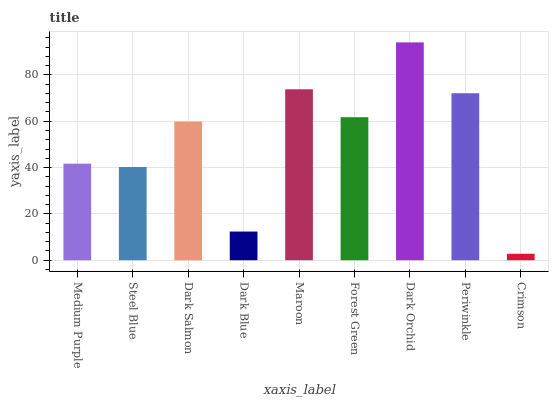Is Crimson the minimum?
Answer yes or no. Yes. Is Dark Orchid the maximum?
Answer yes or no. Yes. Is Steel Blue the minimum?
Answer yes or no. No. Is Steel Blue the maximum?
Answer yes or no. No. Is Medium Purple greater than Steel Blue?
Answer yes or no. Yes. Is Steel Blue less than Medium Purple?
Answer yes or no. Yes. Is Steel Blue greater than Medium Purple?
Answer yes or no. No. Is Medium Purple less than Steel Blue?
Answer yes or no. No. Is Dark Salmon the high median?
Answer yes or no. Yes. Is Dark Salmon the low median?
Answer yes or no. Yes. Is Medium Purple the high median?
Answer yes or no. No. Is Medium Purple the low median?
Answer yes or no. No. 